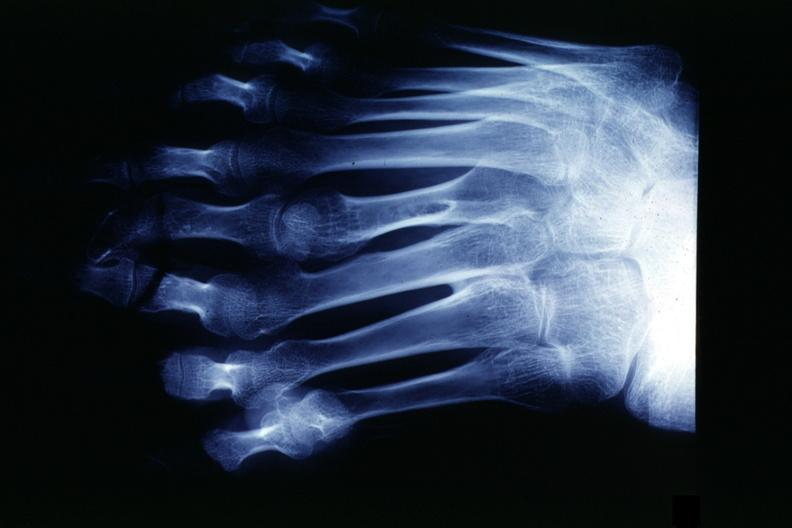s supernumerary digits present?
Answer the question using a single word or phrase. Yes 